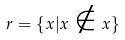<formula> <loc_0><loc_0><loc_500><loc_500>r = \{ x | x \notin x \}</formula> 